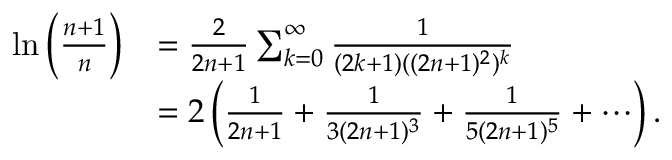<formula> <loc_0><loc_0><loc_500><loc_500>{ \begin{array} { r l } { \ln \left ( { \frac { n + 1 } { n } } \right ) } & { = { \frac { 2 } { 2 n + 1 } } \sum _ { k = 0 } ^ { \infty } { \frac { 1 } { ( 2 k + 1 ) ( ( 2 n + 1 ) ^ { 2 } ) ^ { k } } } } \\ & { = 2 \left ( { \frac { 1 } { 2 n + 1 } } + { \frac { 1 } { 3 ( 2 n + 1 ) ^ { 3 } } } + { \frac { 1 } { 5 ( 2 n + 1 ) ^ { 5 } } } + \cdots \right ) . } \end{array} }</formula> 